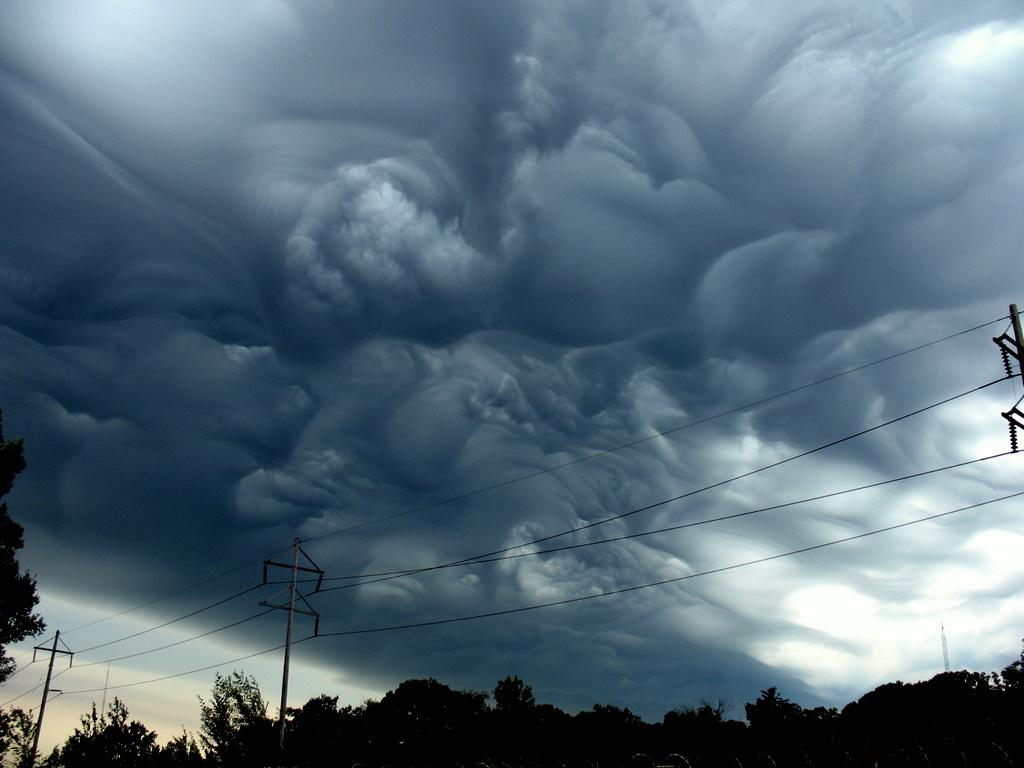What type of vegetation is visible in the image? There are trees in the image. What structures are present in the image that are related to electricity? There are current poles with wires in the image. What is the condition of the sky in the image? The sky is cloudy in the image. How many holes are visible in the image? There are no holes present in the image. What type of coach can be seen in the image? There is no coach present in the image. 